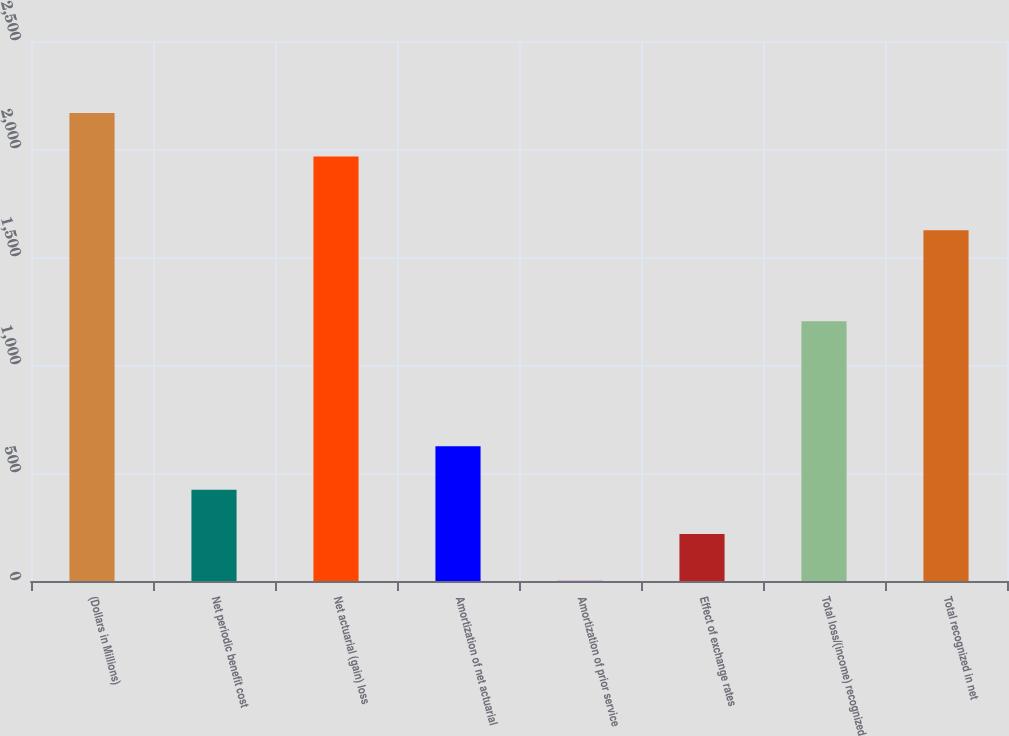Convert chart. <chart><loc_0><loc_0><loc_500><loc_500><bar_chart><fcel>(Dollars in Millions)<fcel>Net periodic benefit cost<fcel>Net actuarial (gain) loss<fcel>Amortization of net actuarial<fcel>Amortization of prior service<fcel>Effect of exchange rates<fcel>Total loss/(income) recognized<fcel>Total recognized in net<nl><fcel>2166.5<fcel>422<fcel>1965<fcel>623.5<fcel>1<fcel>218<fcel>1202<fcel>1624<nl></chart> 